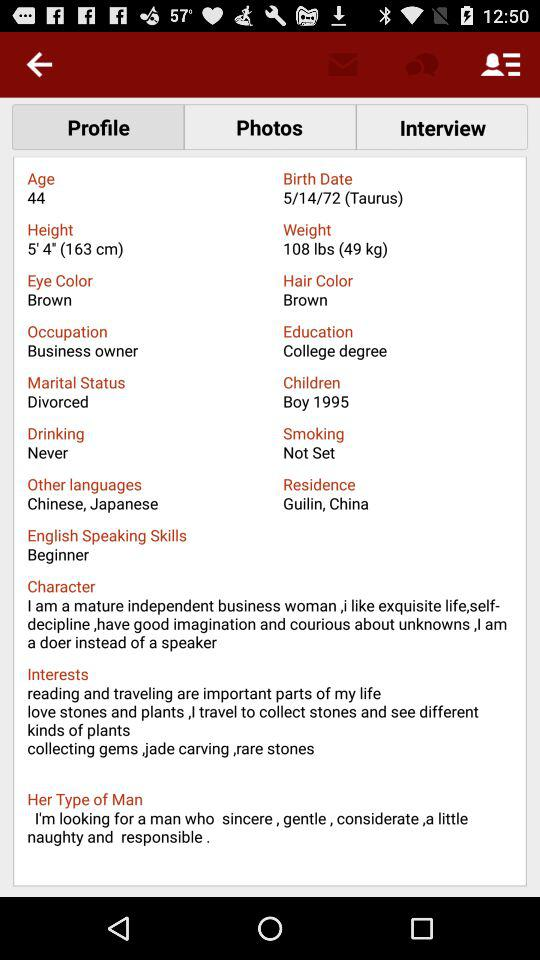Which tab is selected? The selected tab is "Profile". 